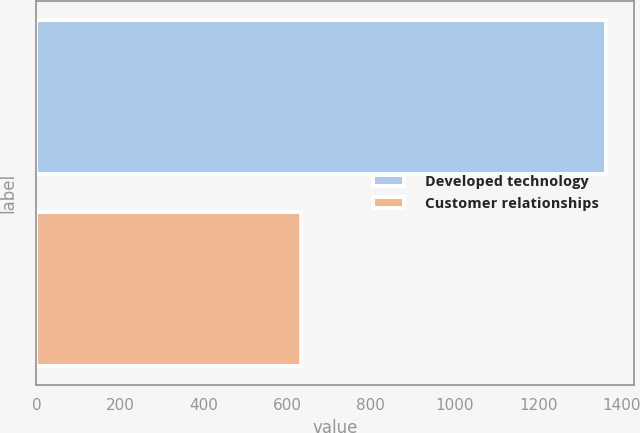<chart> <loc_0><loc_0><loc_500><loc_500><bar_chart><fcel>Developed technology<fcel>Customer relationships<nl><fcel>1361<fcel>633<nl></chart> 